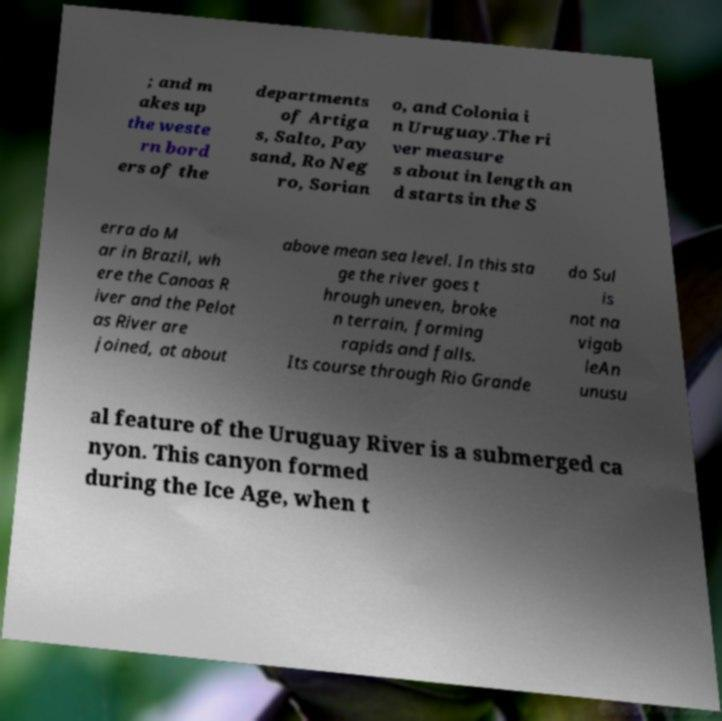There's text embedded in this image that I need extracted. Can you transcribe it verbatim? ; and m akes up the weste rn bord ers of the departments of Artiga s, Salto, Pay sand, Ro Neg ro, Sorian o, and Colonia i n Uruguay.The ri ver measure s about in length an d starts in the S erra do M ar in Brazil, wh ere the Canoas R iver and the Pelot as River are joined, at about above mean sea level. In this sta ge the river goes t hrough uneven, broke n terrain, forming rapids and falls. Its course through Rio Grande do Sul is not na vigab leAn unusu al feature of the Uruguay River is a submerged ca nyon. This canyon formed during the Ice Age, when t 